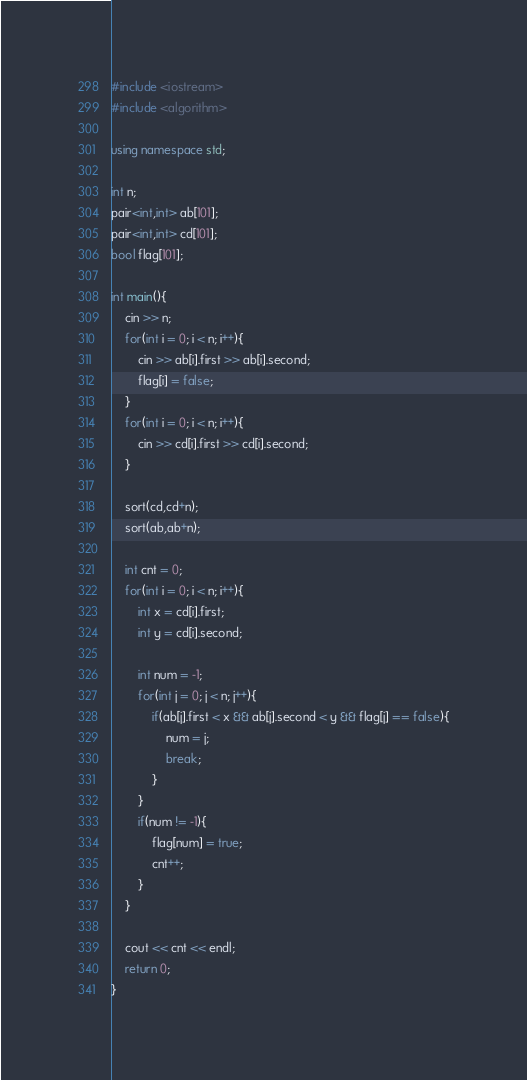Convert code to text. <code><loc_0><loc_0><loc_500><loc_500><_C++_>#include <iostream>
#include <algorithm>

using namespace std;

int n;
pair<int,int> ab[101];
pair<int,int> cd[101];
bool flag[101];

int main(){
    cin >> n;
    for(int i = 0; i < n; i++){
        cin >> ab[i].first >> ab[i].second;
        flag[i] = false;
    }
    for(int i = 0; i < n; i++){
        cin >> cd[i].first >> cd[i].second;
    }

    sort(cd,cd+n);
    sort(ab,ab+n);

    int cnt = 0;
    for(int i = 0; i < n; i++){
        int x = cd[i].first;
        int y = cd[i].second;

        int num = -1;
        for(int j = 0; j < n; j++){
            if(ab[j].first < x && ab[j].second < y && flag[j] == false){
                num = j;
                break;
            }
        }
        if(num != -1){
            flag[num] = true;
            cnt++; 
        }
    }

    cout << cnt << endl;
    return 0;
}

</code> 